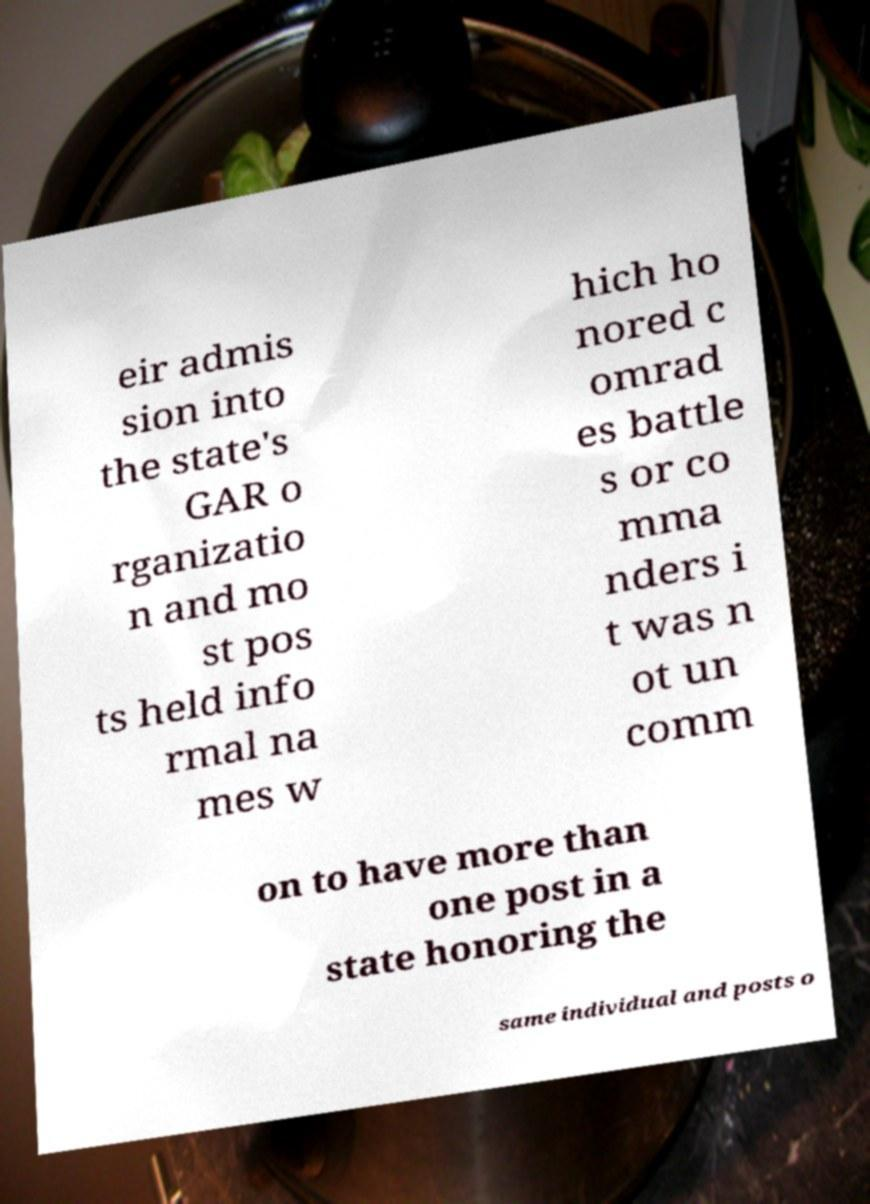I need the written content from this picture converted into text. Can you do that? eir admis sion into the state's GAR o rganizatio n and mo st pos ts held info rmal na mes w hich ho nored c omrad es battle s or co mma nders i t was n ot un comm on to have more than one post in a state honoring the same individual and posts o 